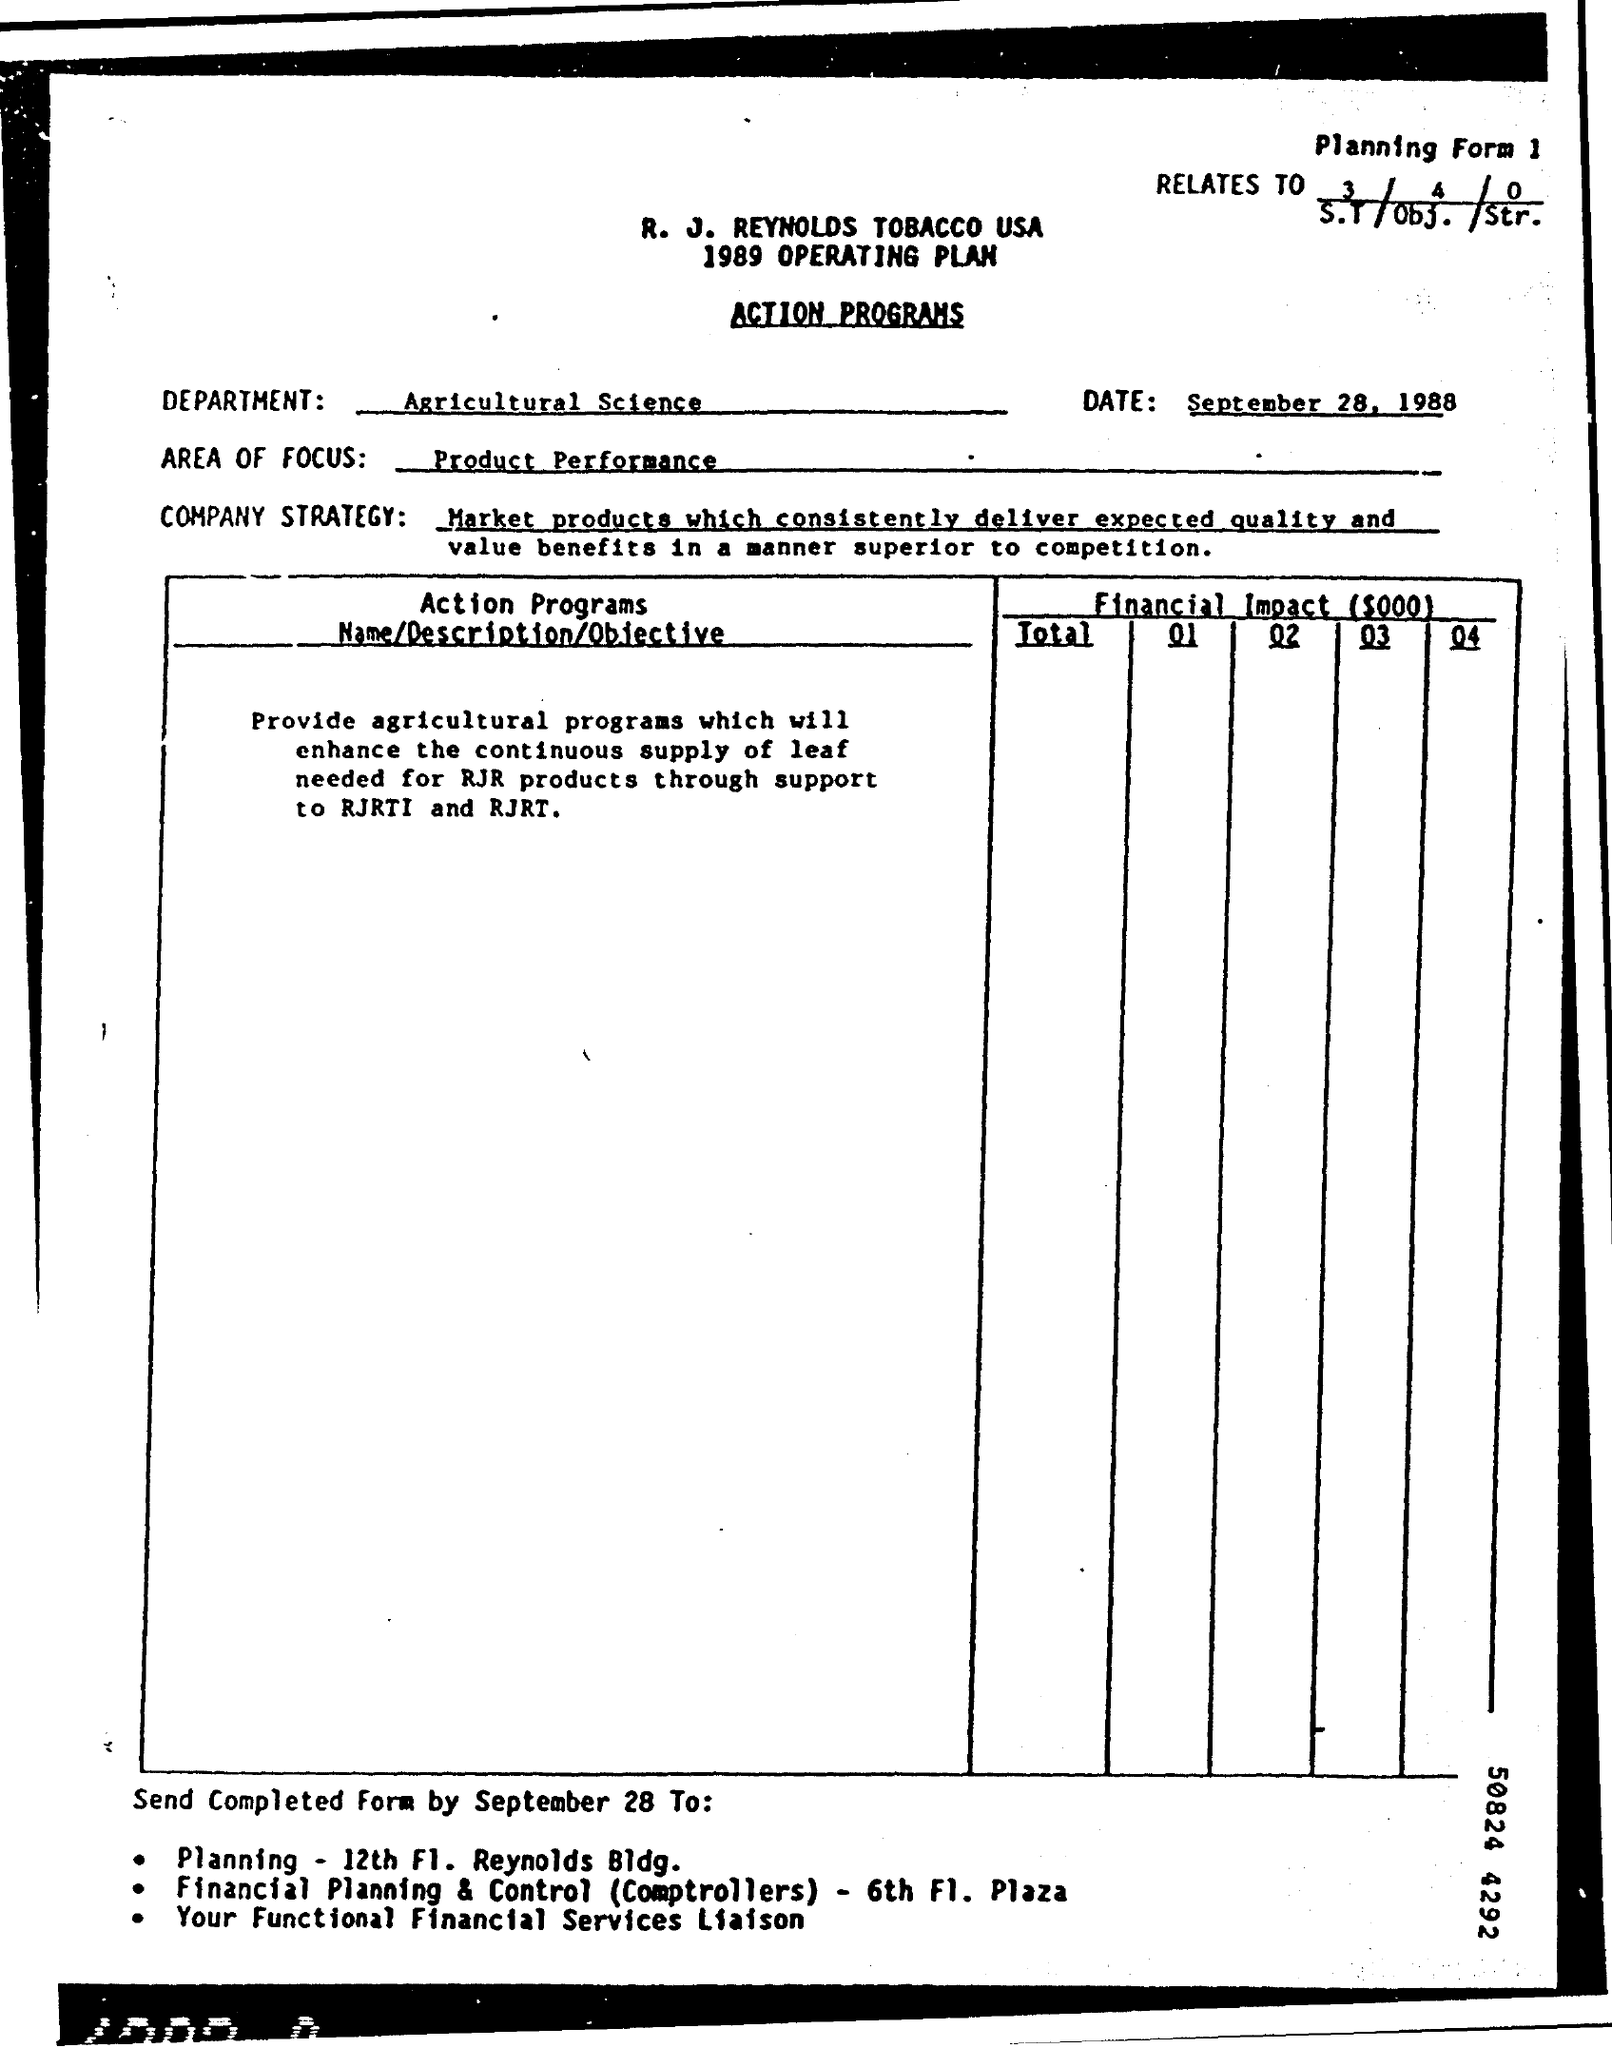Point out several critical features in this image. The department's name mentioned is Agricultural Science. The area of focus written in the page is "Product Performance. On September 28th, the document was sent. 